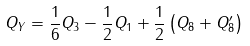<formula> <loc_0><loc_0><loc_500><loc_500>Q _ { Y } = \frac { 1 } { 6 } Q _ { 3 } - \frac { 1 } { 2 } Q _ { 1 } + \frac { 1 } { 2 } \left ( Q _ { 8 } + Q _ { 8 } ^ { \prime } \right )</formula> 